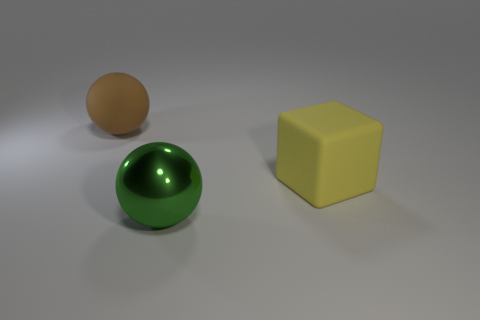There is a sphere on the left side of the metallic ball; what material is it?
Ensure brevity in your answer.  Rubber. What number of green balls are behind the large yellow matte thing that is behind the metal sphere?
Ensure brevity in your answer.  0. Are there any big green matte things of the same shape as the green metal object?
Provide a short and direct response. No. There is a brown thing that is left of the large metallic object; is it the same size as the sphere that is to the right of the large rubber sphere?
Your response must be concise. Yes. What is the shape of the big thing behind the matte object that is in front of the large brown rubber thing?
Ensure brevity in your answer.  Sphere. What number of blocks have the same size as the brown rubber sphere?
Your response must be concise. 1. Are there any green cubes?
Keep it short and to the point. No. Is there any other thing of the same color as the big block?
Keep it short and to the point. No. The other large thing that is made of the same material as the yellow thing is what shape?
Provide a succinct answer. Sphere. There is a rubber thing that is in front of the thing behind the rubber thing in front of the brown matte sphere; what is its color?
Provide a short and direct response. Yellow. 